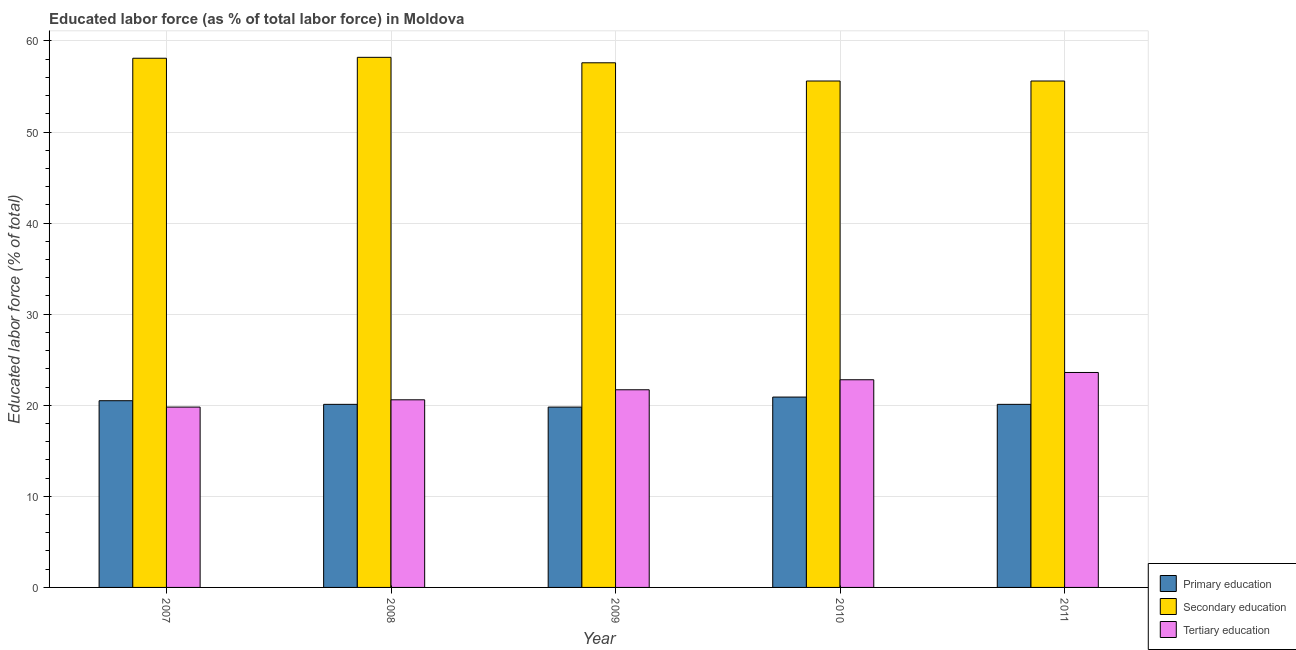How many groups of bars are there?
Your answer should be very brief. 5. Are the number of bars on each tick of the X-axis equal?
Offer a terse response. Yes. How many bars are there on the 4th tick from the left?
Give a very brief answer. 3. How many bars are there on the 1st tick from the right?
Your response must be concise. 3. In how many cases, is the number of bars for a given year not equal to the number of legend labels?
Give a very brief answer. 0. What is the percentage of labor force who received secondary education in 2009?
Provide a short and direct response. 57.6. Across all years, what is the maximum percentage of labor force who received secondary education?
Give a very brief answer. 58.2. Across all years, what is the minimum percentage of labor force who received tertiary education?
Keep it short and to the point. 19.8. In which year was the percentage of labor force who received primary education minimum?
Your answer should be compact. 2009. What is the total percentage of labor force who received secondary education in the graph?
Make the answer very short. 285.1. What is the difference between the percentage of labor force who received secondary education in 2009 and that in 2011?
Keep it short and to the point. 2. What is the difference between the percentage of labor force who received secondary education in 2011 and the percentage of labor force who received tertiary education in 2008?
Your answer should be compact. -2.6. What is the average percentage of labor force who received primary education per year?
Give a very brief answer. 20.28. In how many years, is the percentage of labor force who received tertiary education greater than 36 %?
Make the answer very short. 0. What is the ratio of the percentage of labor force who received primary education in 2008 to that in 2010?
Your answer should be very brief. 0.96. What is the difference between the highest and the second highest percentage of labor force who received secondary education?
Your answer should be compact. 0.1. What is the difference between the highest and the lowest percentage of labor force who received tertiary education?
Your response must be concise. 3.8. In how many years, is the percentage of labor force who received primary education greater than the average percentage of labor force who received primary education taken over all years?
Your answer should be very brief. 2. Is the sum of the percentage of labor force who received primary education in 2008 and 2009 greater than the maximum percentage of labor force who received secondary education across all years?
Your answer should be compact. Yes. What does the 3rd bar from the left in 2008 represents?
Provide a short and direct response. Tertiary education. What does the 1st bar from the right in 2010 represents?
Give a very brief answer. Tertiary education. Is it the case that in every year, the sum of the percentage of labor force who received primary education and percentage of labor force who received secondary education is greater than the percentage of labor force who received tertiary education?
Your answer should be very brief. Yes. How many bars are there?
Offer a terse response. 15. How are the legend labels stacked?
Provide a succinct answer. Vertical. What is the title of the graph?
Your response must be concise. Educated labor force (as % of total labor force) in Moldova. Does "Ages 15-20" appear as one of the legend labels in the graph?
Your answer should be very brief. No. What is the label or title of the Y-axis?
Provide a short and direct response. Educated labor force (% of total). What is the Educated labor force (% of total) in Secondary education in 2007?
Your answer should be compact. 58.1. What is the Educated labor force (% of total) in Tertiary education in 2007?
Provide a succinct answer. 19.8. What is the Educated labor force (% of total) of Primary education in 2008?
Provide a short and direct response. 20.1. What is the Educated labor force (% of total) in Secondary education in 2008?
Give a very brief answer. 58.2. What is the Educated labor force (% of total) in Tertiary education in 2008?
Your answer should be compact. 20.6. What is the Educated labor force (% of total) in Primary education in 2009?
Offer a very short reply. 19.8. What is the Educated labor force (% of total) of Secondary education in 2009?
Provide a succinct answer. 57.6. What is the Educated labor force (% of total) of Tertiary education in 2009?
Your answer should be compact. 21.7. What is the Educated labor force (% of total) of Primary education in 2010?
Make the answer very short. 20.9. What is the Educated labor force (% of total) in Secondary education in 2010?
Make the answer very short. 55.6. What is the Educated labor force (% of total) of Tertiary education in 2010?
Your answer should be compact. 22.8. What is the Educated labor force (% of total) of Primary education in 2011?
Offer a very short reply. 20.1. What is the Educated labor force (% of total) of Secondary education in 2011?
Keep it short and to the point. 55.6. What is the Educated labor force (% of total) of Tertiary education in 2011?
Keep it short and to the point. 23.6. Across all years, what is the maximum Educated labor force (% of total) in Primary education?
Provide a succinct answer. 20.9. Across all years, what is the maximum Educated labor force (% of total) in Secondary education?
Offer a terse response. 58.2. Across all years, what is the maximum Educated labor force (% of total) in Tertiary education?
Your response must be concise. 23.6. Across all years, what is the minimum Educated labor force (% of total) of Primary education?
Your answer should be compact. 19.8. Across all years, what is the minimum Educated labor force (% of total) of Secondary education?
Offer a very short reply. 55.6. Across all years, what is the minimum Educated labor force (% of total) in Tertiary education?
Make the answer very short. 19.8. What is the total Educated labor force (% of total) of Primary education in the graph?
Give a very brief answer. 101.4. What is the total Educated labor force (% of total) in Secondary education in the graph?
Provide a short and direct response. 285.1. What is the total Educated labor force (% of total) in Tertiary education in the graph?
Give a very brief answer. 108.5. What is the difference between the Educated labor force (% of total) of Primary education in 2007 and that in 2008?
Your response must be concise. 0.4. What is the difference between the Educated labor force (% of total) in Tertiary education in 2007 and that in 2008?
Your answer should be very brief. -0.8. What is the difference between the Educated labor force (% of total) in Tertiary education in 2007 and that in 2009?
Keep it short and to the point. -1.9. What is the difference between the Educated labor force (% of total) in Primary education in 2007 and that in 2010?
Offer a terse response. -0.4. What is the difference between the Educated labor force (% of total) of Primary education in 2007 and that in 2011?
Make the answer very short. 0.4. What is the difference between the Educated labor force (% of total) in Tertiary education in 2007 and that in 2011?
Offer a very short reply. -3.8. What is the difference between the Educated labor force (% of total) of Primary education in 2008 and that in 2009?
Your response must be concise. 0.3. What is the difference between the Educated labor force (% of total) of Tertiary education in 2008 and that in 2009?
Give a very brief answer. -1.1. What is the difference between the Educated labor force (% of total) of Tertiary education in 2008 and that in 2010?
Your response must be concise. -2.2. What is the difference between the Educated labor force (% of total) in Secondary education in 2008 and that in 2011?
Keep it short and to the point. 2.6. What is the difference between the Educated labor force (% of total) of Tertiary education in 2008 and that in 2011?
Provide a succinct answer. -3. What is the difference between the Educated labor force (% of total) of Secondary education in 2009 and that in 2010?
Your answer should be compact. 2. What is the difference between the Educated labor force (% of total) of Tertiary education in 2009 and that in 2010?
Give a very brief answer. -1.1. What is the difference between the Educated labor force (% of total) in Primary education in 2009 and that in 2011?
Keep it short and to the point. -0.3. What is the difference between the Educated labor force (% of total) of Tertiary education in 2009 and that in 2011?
Make the answer very short. -1.9. What is the difference between the Educated labor force (% of total) in Primary education in 2010 and that in 2011?
Offer a very short reply. 0.8. What is the difference between the Educated labor force (% of total) of Primary education in 2007 and the Educated labor force (% of total) of Secondary education in 2008?
Ensure brevity in your answer.  -37.7. What is the difference between the Educated labor force (% of total) of Primary education in 2007 and the Educated labor force (% of total) of Tertiary education in 2008?
Give a very brief answer. -0.1. What is the difference between the Educated labor force (% of total) of Secondary education in 2007 and the Educated labor force (% of total) of Tertiary education in 2008?
Your answer should be very brief. 37.5. What is the difference between the Educated labor force (% of total) of Primary education in 2007 and the Educated labor force (% of total) of Secondary education in 2009?
Your answer should be very brief. -37.1. What is the difference between the Educated labor force (% of total) of Primary education in 2007 and the Educated labor force (% of total) of Tertiary education in 2009?
Offer a very short reply. -1.2. What is the difference between the Educated labor force (% of total) of Secondary education in 2007 and the Educated labor force (% of total) of Tertiary education in 2009?
Your answer should be compact. 36.4. What is the difference between the Educated labor force (% of total) in Primary education in 2007 and the Educated labor force (% of total) in Secondary education in 2010?
Your answer should be compact. -35.1. What is the difference between the Educated labor force (% of total) in Primary education in 2007 and the Educated labor force (% of total) in Tertiary education in 2010?
Make the answer very short. -2.3. What is the difference between the Educated labor force (% of total) of Secondary education in 2007 and the Educated labor force (% of total) of Tertiary education in 2010?
Keep it short and to the point. 35.3. What is the difference between the Educated labor force (% of total) of Primary education in 2007 and the Educated labor force (% of total) of Secondary education in 2011?
Offer a very short reply. -35.1. What is the difference between the Educated labor force (% of total) in Secondary education in 2007 and the Educated labor force (% of total) in Tertiary education in 2011?
Provide a short and direct response. 34.5. What is the difference between the Educated labor force (% of total) of Primary education in 2008 and the Educated labor force (% of total) of Secondary education in 2009?
Offer a terse response. -37.5. What is the difference between the Educated labor force (% of total) in Secondary education in 2008 and the Educated labor force (% of total) in Tertiary education in 2009?
Provide a short and direct response. 36.5. What is the difference between the Educated labor force (% of total) in Primary education in 2008 and the Educated labor force (% of total) in Secondary education in 2010?
Give a very brief answer. -35.5. What is the difference between the Educated labor force (% of total) in Primary education in 2008 and the Educated labor force (% of total) in Tertiary education in 2010?
Keep it short and to the point. -2.7. What is the difference between the Educated labor force (% of total) in Secondary education in 2008 and the Educated labor force (% of total) in Tertiary education in 2010?
Provide a short and direct response. 35.4. What is the difference between the Educated labor force (% of total) in Primary education in 2008 and the Educated labor force (% of total) in Secondary education in 2011?
Offer a very short reply. -35.5. What is the difference between the Educated labor force (% of total) in Secondary education in 2008 and the Educated labor force (% of total) in Tertiary education in 2011?
Provide a succinct answer. 34.6. What is the difference between the Educated labor force (% of total) in Primary education in 2009 and the Educated labor force (% of total) in Secondary education in 2010?
Offer a terse response. -35.8. What is the difference between the Educated labor force (% of total) in Primary education in 2009 and the Educated labor force (% of total) in Tertiary education in 2010?
Ensure brevity in your answer.  -3. What is the difference between the Educated labor force (% of total) in Secondary education in 2009 and the Educated labor force (% of total) in Tertiary education in 2010?
Your answer should be very brief. 34.8. What is the difference between the Educated labor force (% of total) in Primary education in 2009 and the Educated labor force (% of total) in Secondary education in 2011?
Keep it short and to the point. -35.8. What is the difference between the Educated labor force (% of total) in Secondary education in 2009 and the Educated labor force (% of total) in Tertiary education in 2011?
Your answer should be very brief. 34. What is the difference between the Educated labor force (% of total) in Primary education in 2010 and the Educated labor force (% of total) in Secondary education in 2011?
Offer a very short reply. -34.7. What is the average Educated labor force (% of total) in Primary education per year?
Your answer should be compact. 20.28. What is the average Educated labor force (% of total) of Secondary education per year?
Offer a terse response. 57.02. What is the average Educated labor force (% of total) in Tertiary education per year?
Offer a very short reply. 21.7. In the year 2007, what is the difference between the Educated labor force (% of total) in Primary education and Educated labor force (% of total) in Secondary education?
Make the answer very short. -37.6. In the year 2007, what is the difference between the Educated labor force (% of total) of Secondary education and Educated labor force (% of total) of Tertiary education?
Provide a short and direct response. 38.3. In the year 2008, what is the difference between the Educated labor force (% of total) in Primary education and Educated labor force (% of total) in Secondary education?
Ensure brevity in your answer.  -38.1. In the year 2008, what is the difference between the Educated labor force (% of total) of Secondary education and Educated labor force (% of total) of Tertiary education?
Keep it short and to the point. 37.6. In the year 2009, what is the difference between the Educated labor force (% of total) in Primary education and Educated labor force (% of total) in Secondary education?
Provide a short and direct response. -37.8. In the year 2009, what is the difference between the Educated labor force (% of total) in Secondary education and Educated labor force (% of total) in Tertiary education?
Your answer should be compact. 35.9. In the year 2010, what is the difference between the Educated labor force (% of total) in Primary education and Educated labor force (% of total) in Secondary education?
Your response must be concise. -34.7. In the year 2010, what is the difference between the Educated labor force (% of total) in Secondary education and Educated labor force (% of total) in Tertiary education?
Your response must be concise. 32.8. In the year 2011, what is the difference between the Educated labor force (% of total) of Primary education and Educated labor force (% of total) of Secondary education?
Provide a short and direct response. -35.5. In the year 2011, what is the difference between the Educated labor force (% of total) in Secondary education and Educated labor force (% of total) in Tertiary education?
Offer a very short reply. 32. What is the ratio of the Educated labor force (% of total) in Primary education in 2007 to that in 2008?
Your answer should be compact. 1.02. What is the ratio of the Educated labor force (% of total) in Secondary education in 2007 to that in 2008?
Your answer should be very brief. 1. What is the ratio of the Educated labor force (% of total) in Tertiary education in 2007 to that in 2008?
Your answer should be very brief. 0.96. What is the ratio of the Educated labor force (% of total) of Primary education in 2007 to that in 2009?
Provide a short and direct response. 1.04. What is the ratio of the Educated labor force (% of total) of Secondary education in 2007 to that in 2009?
Your answer should be very brief. 1.01. What is the ratio of the Educated labor force (% of total) of Tertiary education in 2007 to that in 2009?
Make the answer very short. 0.91. What is the ratio of the Educated labor force (% of total) in Primary education in 2007 to that in 2010?
Your answer should be very brief. 0.98. What is the ratio of the Educated labor force (% of total) in Secondary education in 2007 to that in 2010?
Your answer should be compact. 1.04. What is the ratio of the Educated labor force (% of total) of Tertiary education in 2007 to that in 2010?
Make the answer very short. 0.87. What is the ratio of the Educated labor force (% of total) of Primary education in 2007 to that in 2011?
Your answer should be very brief. 1.02. What is the ratio of the Educated labor force (% of total) of Secondary education in 2007 to that in 2011?
Keep it short and to the point. 1.04. What is the ratio of the Educated labor force (% of total) of Tertiary education in 2007 to that in 2011?
Keep it short and to the point. 0.84. What is the ratio of the Educated labor force (% of total) of Primary education in 2008 to that in 2009?
Provide a short and direct response. 1.02. What is the ratio of the Educated labor force (% of total) in Secondary education in 2008 to that in 2009?
Provide a short and direct response. 1.01. What is the ratio of the Educated labor force (% of total) of Tertiary education in 2008 to that in 2009?
Offer a very short reply. 0.95. What is the ratio of the Educated labor force (% of total) of Primary education in 2008 to that in 2010?
Offer a terse response. 0.96. What is the ratio of the Educated labor force (% of total) of Secondary education in 2008 to that in 2010?
Ensure brevity in your answer.  1.05. What is the ratio of the Educated labor force (% of total) in Tertiary education in 2008 to that in 2010?
Keep it short and to the point. 0.9. What is the ratio of the Educated labor force (% of total) of Primary education in 2008 to that in 2011?
Offer a terse response. 1. What is the ratio of the Educated labor force (% of total) of Secondary education in 2008 to that in 2011?
Provide a short and direct response. 1.05. What is the ratio of the Educated labor force (% of total) of Tertiary education in 2008 to that in 2011?
Your answer should be compact. 0.87. What is the ratio of the Educated labor force (% of total) of Secondary education in 2009 to that in 2010?
Offer a very short reply. 1.04. What is the ratio of the Educated labor force (% of total) of Tertiary education in 2009 to that in 2010?
Your response must be concise. 0.95. What is the ratio of the Educated labor force (% of total) of Primary education in 2009 to that in 2011?
Your answer should be very brief. 0.99. What is the ratio of the Educated labor force (% of total) in Secondary education in 2009 to that in 2011?
Ensure brevity in your answer.  1.04. What is the ratio of the Educated labor force (% of total) in Tertiary education in 2009 to that in 2011?
Your answer should be very brief. 0.92. What is the ratio of the Educated labor force (% of total) of Primary education in 2010 to that in 2011?
Provide a short and direct response. 1.04. What is the ratio of the Educated labor force (% of total) of Secondary education in 2010 to that in 2011?
Offer a very short reply. 1. What is the ratio of the Educated labor force (% of total) of Tertiary education in 2010 to that in 2011?
Your answer should be compact. 0.97. What is the difference between the highest and the second highest Educated labor force (% of total) in Primary education?
Keep it short and to the point. 0.4. What is the difference between the highest and the second highest Educated labor force (% of total) in Tertiary education?
Keep it short and to the point. 0.8. 